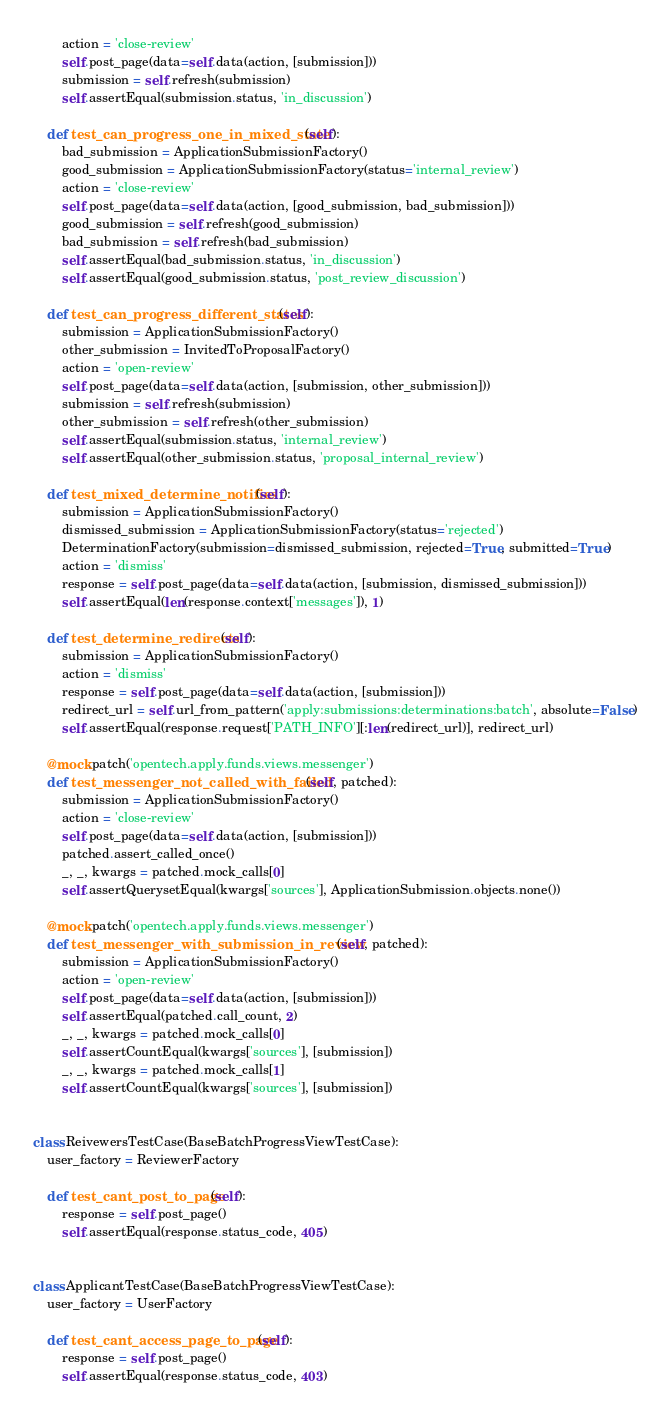Convert code to text. <code><loc_0><loc_0><loc_500><loc_500><_Python_>        action = 'close-review'
        self.post_page(data=self.data(action, [submission]))
        submission = self.refresh(submission)
        self.assertEqual(submission.status, 'in_discussion')

    def test_can_progress_one_in_mixed_state(self):
        bad_submission = ApplicationSubmissionFactory()
        good_submission = ApplicationSubmissionFactory(status='internal_review')
        action = 'close-review'
        self.post_page(data=self.data(action, [good_submission, bad_submission]))
        good_submission = self.refresh(good_submission)
        bad_submission = self.refresh(bad_submission)
        self.assertEqual(bad_submission.status, 'in_discussion')
        self.assertEqual(good_submission.status, 'post_review_discussion')

    def test_can_progress_different_states(self):
        submission = ApplicationSubmissionFactory()
        other_submission = InvitedToProposalFactory()
        action = 'open-review'
        self.post_page(data=self.data(action, [submission, other_submission]))
        submission = self.refresh(submission)
        other_submission = self.refresh(other_submission)
        self.assertEqual(submission.status, 'internal_review')
        self.assertEqual(other_submission.status, 'proposal_internal_review')

    def test_mixed_determine_notifies(self):
        submission = ApplicationSubmissionFactory()
        dismissed_submission = ApplicationSubmissionFactory(status='rejected')
        DeterminationFactory(submission=dismissed_submission, rejected=True, submitted=True)
        action = 'dismiss'
        response = self.post_page(data=self.data(action, [submission, dismissed_submission]))
        self.assertEqual(len(response.context['messages']), 1)

    def test_determine_redirects(self):
        submission = ApplicationSubmissionFactory()
        action = 'dismiss'
        response = self.post_page(data=self.data(action, [submission]))
        redirect_url = self.url_from_pattern('apply:submissions:determinations:batch', absolute=False)
        self.assertEqual(response.request['PATH_INFO'][:len(redirect_url)], redirect_url)

    @mock.patch('opentech.apply.funds.views.messenger')
    def test_messenger_not_called_with_failed(self, patched):
        submission = ApplicationSubmissionFactory()
        action = 'close-review'
        self.post_page(data=self.data(action, [submission]))
        patched.assert_called_once()
        _, _, kwargs = patched.mock_calls[0]
        self.assertQuerysetEqual(kwargs['sources'], ApplicationSubmission.objects.none())

    @mock.patch('opentech.apply.funds.views.messenger')
    def test_messenger_with_submission_in_review(self, patched):
        submission = ApplicationSubmissionFactory()
        action = 'open-review'
        self.post_page(data=self.data(action, [submission]))
        self.assertEqual(patched.call_count, 2)
        _, _, kwargs = patched.mock_calls[0]
        self.assertCountEqual(kwargs['sources'], [submission])
        _, _, kwargs = patched.mock_calls[1]
        self.assertCountEqual(kwargs['sources'], [submission])


class ReivewersTestCase(BaseBatchProgressViewTestCase):
    user_factory = ReviewerFactory

    def test_cant_post_to_page(self):
        response = self.post_page()
        self.assertEqual(response.status_code, 405)


class ApplicantTestCase(BaseBatchProgressViewTestCase):
    user_factory = UserFactory

    def test_cant_access_page_to_page(self):
        response = self.post_page()
        self.assertEqual(response.status_code, 403)
</code> 